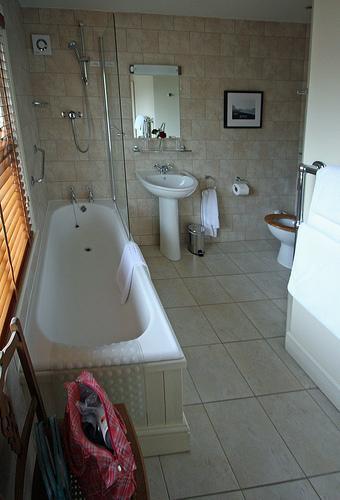How many towels are visible?
Give a very brief answer. 4. 